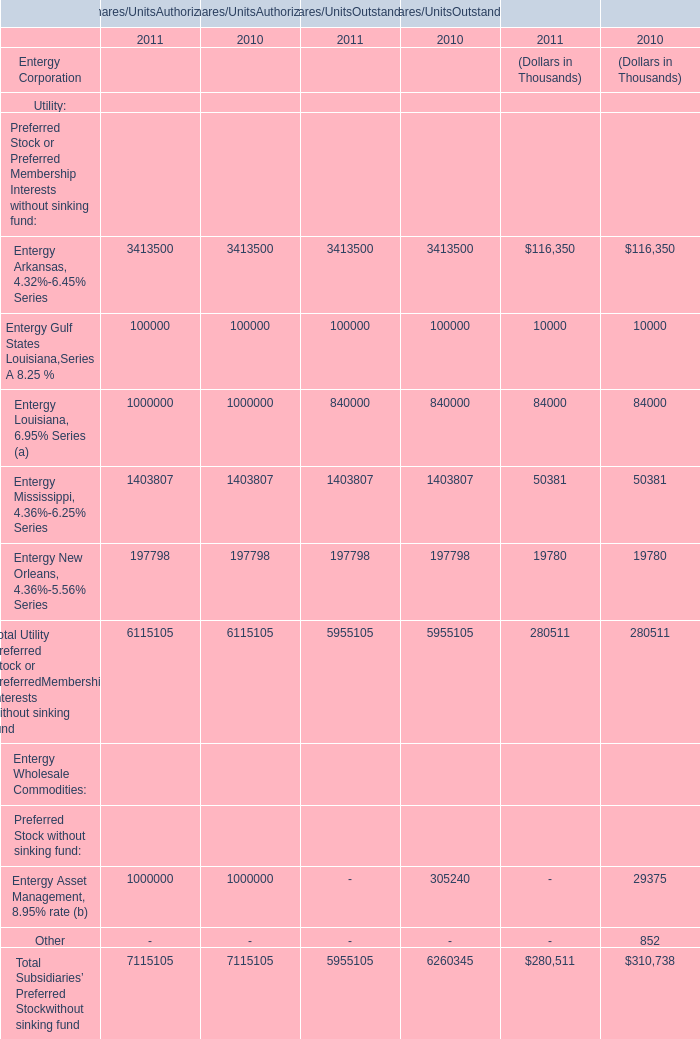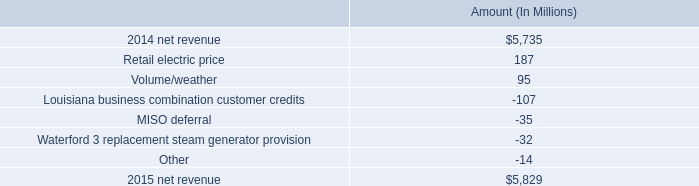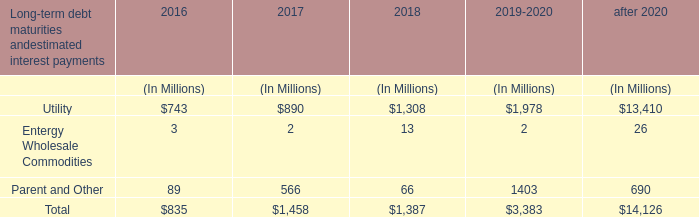based on the analysis of the change in net revenue from 2014 to 2015 what was the percent of the change 
Computations: ((5829 - 5735) / 5735)
Answer: 0.01639. 